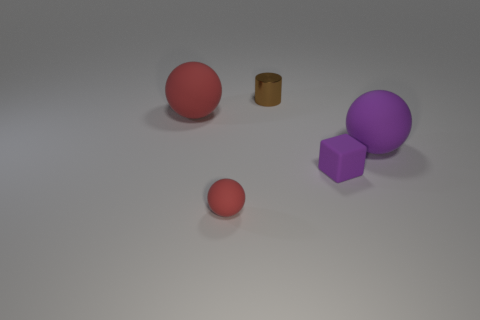How many big rubber things are the same color as the small rubber sphere?
Make the answer very short. 1. What is the shape of the purple rubber thing left of the big rubber ball that is to the right of the tiny brown cylinder?
Offer a terse response. Cube. How many small purple things have the same material as the small purple block?
Your response must be concise. 0. What material is the small object on the left side of the tiny brown metallic cylinder?
Your answer should be compact. Rubber. The purple object to the left of the large ball that is in front of the big object left of the small metallic cylinder is what shape?
Your answer should be compact. Cube. Is the color of the big rubber sphere that is in front of the big red object the same as the small rubber object behind the small sphere?
Your answer should be compact. Yes. Is the number of large purple things that are in front of the small sphere less than the number of blocks on the right side of the large red rubber object?
Offer a very short reply. Yes. Is there anything else that is the same shape as the big purple object?
Keep it short and to the point. Yes. The other big object that is the same shape as the large purple object is what color?
Ensure brevity in your answer.  Red. Do the small metal thing and the matte thing in front of the tiny rubber block have the same shape?
Offer a terse response. No. 